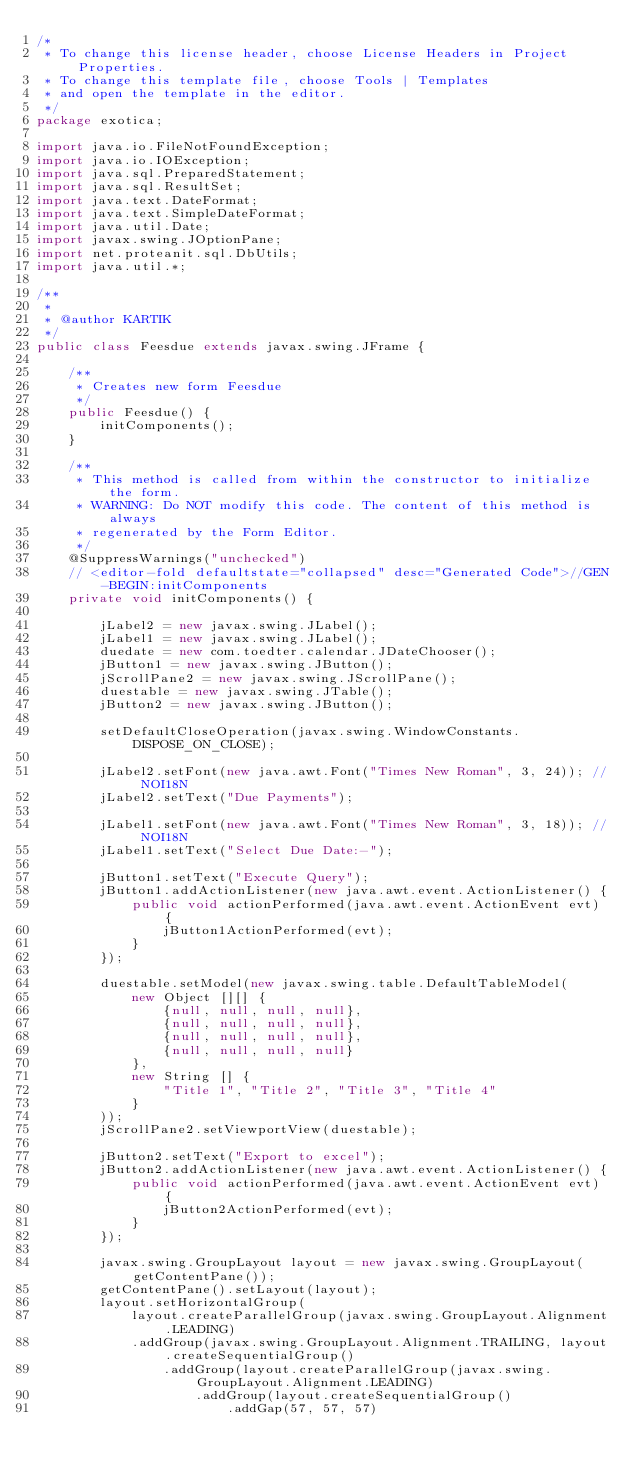<code> <loc_0><loc_0><loc_500><loc_500><_Java_>/*
 * To change this license header, choose License Headers in Project Properties.
 * To change this template file, choose Tools | Templates
 * and open the template in the editor.
 */
package exotica;

import java.io.FileNotFoundException;
import java.io.IOException;
import java.sql.PreparedStatement;
import java.sql.ResultSet;
import java.text.DateFormat;
import java.text.SimpleDateFormat;
import java.util.Date;
import javax.swing.JOptionPane;
import net.proteanit.sql.DbUtils;
import java.util.*;

/**
 *
 * @author KARTIK
 */
public class Feesdue extends javax.swing.JFrame {

    /**
     * Creates new form Feesdue
     */
    public Feesdue() {
        initComponents();
    }

    /**
     * This method is called from within the constructor to initialize the form.
     * WARNING: Do NOT modify this code. The content of this method is always
     * regenerated by the Form Editor.
     */
    @SuppressWarnings("unchecked")
    // <editor-fold defaultstate="collapsed" desc="Generated Code">//GEN-BEGIN:initComponents
    private void initComponents() {

        jLabel2 = new javax.swing.JLabel();
        jLabel1 = new javax.swing.JLabel();
        duedate = new com.toedter.calendar.JDateChooser();
        jButton1 = new javax.swing.JButton();
        jScrollPane2 = new javax.swing.JScrollPane();
        duestable = new javax.swing.JTable();
        jButton2 = new javax.swing.JButton();

        setDefaultCloseOperation(javax.swing.WindowConstants.DISPOSE_ON_CLOSE);

        jLabel2.setFont(new java.awt.Font("Times New Roman", 3, 24)); // NOI18N
        jLabel2.setText("Due Payments");

        jLabel1.setFont(new java.awt.Font("Times New Roman", 3, 18)); // NOI18N
        jLabel1.setText("Select Due Date:-");

        jButton1.setText("Execute Query");
        jButton1.addActionListener(new java.awt.event.ActionListener() {
            public void actionPerformed(java.awt.event.ActionEvent evt) {
                jButton1ActionPerformed(evt);
            }
        });

        duestable.setModel(new javax.swing.table.DefaultTableModel(
            new Object [][] {
                {null, null, null, null},
                {null, null, null, null},
                {null, null, null, null},
                {null, null, null, null}
            },
            new String [] {
                "Title 1", "Title 2", "Title 3", "Title 4"
            }
        ));
        jScrollPane2.setViewportView(duestable);

        jButton2.setText("Export to excel");
        jButton2.addActionListener(new java.awt.event.ActionListener() {
            public void actionPerformed(java.awt.event.ActionEvent evt) {
                jButton2ActionPerformed(evt);
            }
        });

        javax.swing.GroupLayout layout = new javax.swing.GroupLayout(getContentPane());
        getContentPane().setLayout(layout);
        layout.setHorizontalGroup(
            layout.createParallelGroup(javax.swing.GroupLayout.Alignment.LEADING)
            .addGroup(javax.swing.GroupLayout.Alignment.TRAILING, layout.createSequentialGroup()
                .addGroup(layout.createParallelGroup(javax.swing.GroupLayout.Alignment.LEADING)
                    .addGroup(layout.createSequentialGroup()
                        .addGap(57, 57, 57)</code> 